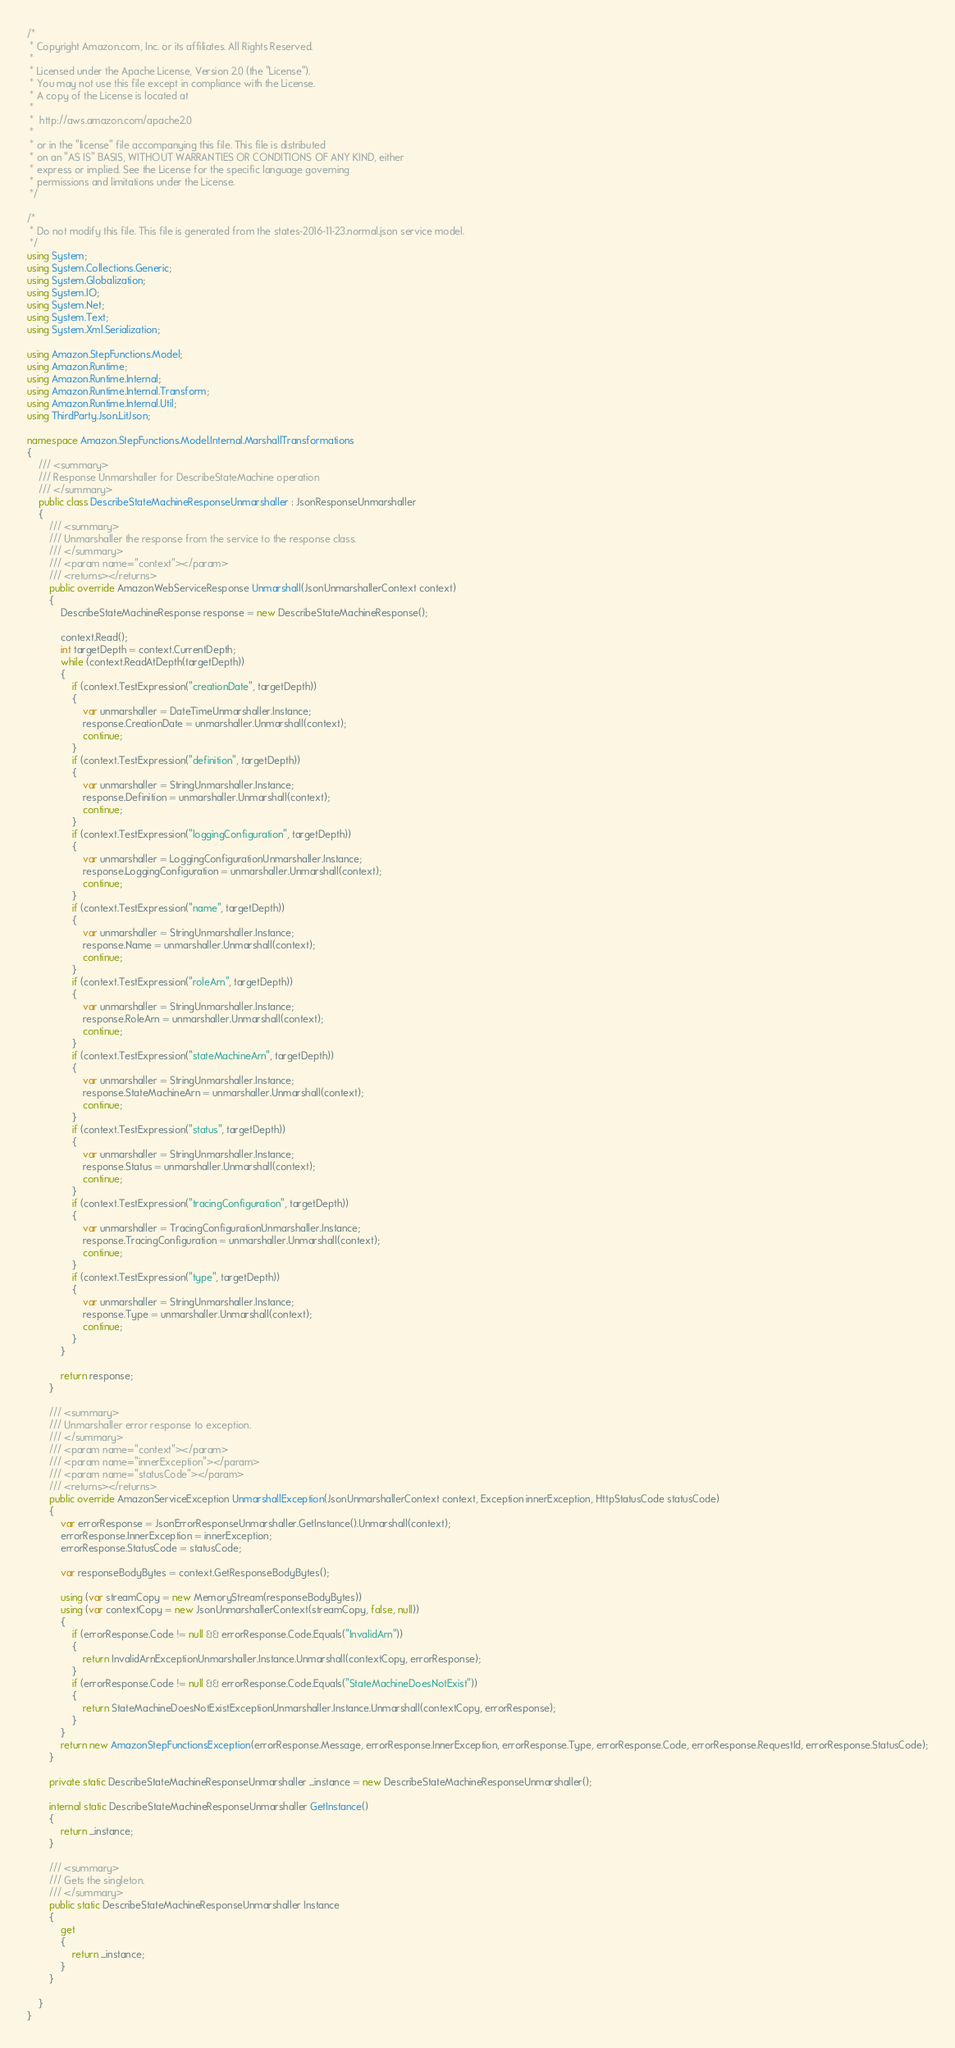<code> <loc_0><loc_0><loc_500><loc_500><_C#_>/*
 * Copyright Amazon.com, Inc. or its affiliates. All Rights Reserved.
 * 
 * Licensed under the Apache License, Version 2.0 (the "License").
 * You may not use this file except in compliance with the License.
 * A copy of the License is located at
 * 
 *  http://aws.amazon.com/apache2.0
 * 
 * or in the "license" file accompanying this file. This file is distributed
 * on an "AS IS" BASIS, WITHOUT WARRANTIES OR CONDITIONS OF ANY KIND, either
 * express or implied. See the License for the specific language governing
 * permissions and limitations under the License.
 */

/*
 * Do not modify this file. This file is generated from the states-2016-11-23.normal.json service model.
 */
using System;
using System.Collections.Generic;
using System.Globalization;
using System.IO;
using System.Net;
using System.Text;
using System.Xml.Serialization;

using Amazon.StepFunctions.Model;
using Amazon.Runtime;
using Amazon.Runtime.Internal;
using Amazon.Runtime.Internal.Transform;
using Amazon.Runtime.Internal.Util;
using ThirdParty.Json.LitJson;

namespace Amazon.StepFunctions.Model.Internal.MarshallTransformations
{
    /// <summary>
    /// Response Unmarshaller for DescribeStateMachine operation
    /// </summary>  
    public class DescribeStateMachineResponseUnmarshaller : JsonResponseUnmarshaller
    {
        /// <summary>
        /// Unmarshaller the response from the service to the response class.
        /// </summary>  
        /// <param name="context"></param>
        /// <returns></returns>
        public override AmazonWebServiceResponse Unmarshall(JsonUnmarshallerContext context)
        {
            DescribeStateMachineResponse response = new DescribeStateMachineResponse();

            context.Read();
            int targetDepth = context.CurrentDepth;
            while (context.ReadAtDepth(targetDepth))
            {
                if (context.TestExpression("creationDate", targetDepth))
                {
                    var unmarshaller = DateTimeUnmarshaller.Instance;
                    response.CreationDate = unmarshaller.Unmarshall(context);
                    continue;
                }
                if (context.TestExpression("definition", targetDepth))
                {
                    var unmarshaller = StringUnmarshaller.Instance;
                    response.Definition = unmarshaller.Unmarshall(context);
                    continue;
                }
                if (context.TestExpression("loggingConfiguration", targetDepth))
                {
                    var unmarshaller = LoggingConfigurationUnmarshaller.Instance;
                    response.LoggingConfiguration = unmarshaller.Unmarshall(context);
                    continue;
                }
                if (context.TestExpression("name", targetDepth))
                {
                    var unmarshaller = StringUnmarshaller.Instance;
                    response.Name = unmarshaller.Unmarshall(context);
                    continue;
                }
                if (context.TestExpression("roleArn", targetDepth))
                {
                    var unmarshaller = StringUnmarshaller.Instance;
                    response.RoleArn = unmarshaller.Unmarshall(context);
                    continue;
                }
                if (context.TestExpression("stateMachineArn", targetDepth))
                {
                    var unmarshaller = StringUnmarshaller.Instance;
                    response.StateMachineArn = unmarshaller.Unmarshall(context);
                    continue;
                }
                if (context.TestExpression("status", targetDepth))
                {
                    var unmarshaller = StringUnmarshaller.Instance;
                    response.Status = unmarshaller.Unmarshall(context);
                    continue;
                }
                if (context.TestExpression("tracingConfiguration", targetDepth))
                {
                    var unmarshaller = TracingConfigurationUnmarshaller.Instance;
                    response.TracingConfiguration = unmarshaller.Unmarshall(context);
                    continue;
                }
                if (context.TestExpression("type", targetDepth))
                {
                    var unmarshaller = StringUnmarshaller.Instance;
                    response.Type = unmarshaller.Unmarshall(context);
                    continue;
                }
            }

            return response;
        }

        /// <summary>
        /// Unmarshaller error response to exception.
        /// </summary>  
        /// <param name="context"></param>
        /// <param name="innerException"></param>
        /// <param name="statusCode"></param>
        /// <returns></returns>
        public override AmazonServiceException UnmarshallException(JsonUnmarshallerContext context, Exception innerException, HttpStatusCode statusCode)
        {
            var errorResponse = JsonErrorResponseUnmarshaller.GetInstance().Unmarshall(context);
            errorResponse.InnerException = innerException;
            errorResponse.StatusCode = statusCode;

            var responseBodyBytes = context.GetResponseBodyBytes();

            using (var streamCopy = new MemoryStream(responseBodyBytes))
            using (var contextCopy = new JsonUnmarshallerContext(streamCopy, false, null))
            {
                if (errorResponse.Code != null && errorResponse.Code.Equals("InvalidArn"))
                {
                    return InvalidArnExceptionUnmarshaller.Instance.Unmarshall(contextCopy, errorResponse);
                }
                if (errorResponse.Code != null && errorResponse.Code.Equals("StateMachineDoesNotExist"))
                {
                    return StateMachineDoesNotExistExceptionUnmarshaller.Instance.Unmarshall(contextCopy, errorResponse);
                }
            }
            return new AmazonStepFunctionsException(errorResponse.Message, errorResponse.InnerException, errorResponse.Type, errorResponse.Code, errorResponse.RequestId, errorResponse.StatusCode);
        }

        private static DescribeStateMachineResponseUnmarshaller _instance = new DescribeStateMachineResponseUnmarshaller();        

        internal static DescribeStateMachineResponseUnmarshaller GetInstance()
        {
            return _instance;
        }

        /// <summary>
        /// Gets the singleton.
        /// </summary>  
        public static DescribeStateMachineResponseUnmarshaller Instance
        {
            get
            {
                return _instance;
            }
        }

    }
}</code> 